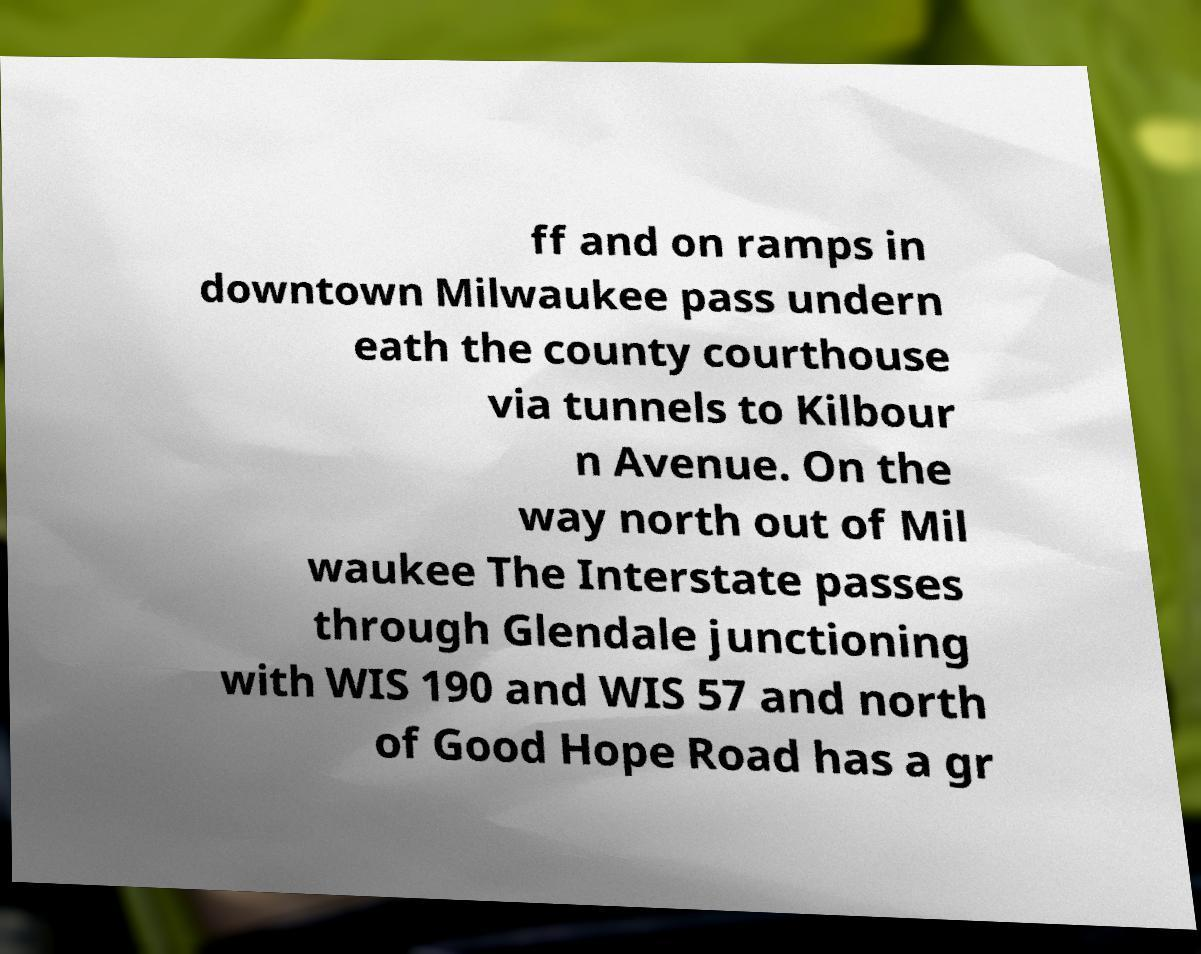Could you assist in decoding the text presented in this image and type it out clearly? ff and on ramps in downtown Milwaukee pass undern eath the county courthouse via tunnels to Kilbour n Avenue. On the way north out of Mil waukee The Interstate passes through Glendale junctioning with WIS 190 and WIS 57 and north of Good Hope Road has a gr 